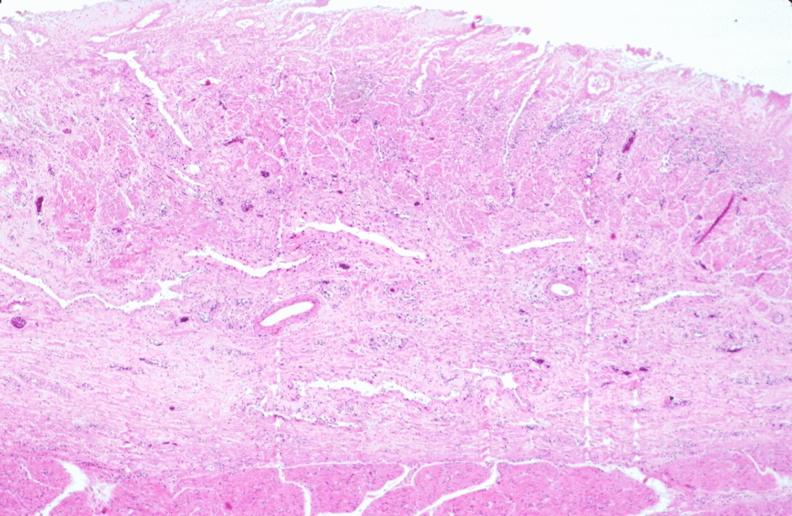s intramural one lesion present?
Answer the question using a single word or phrase. No 